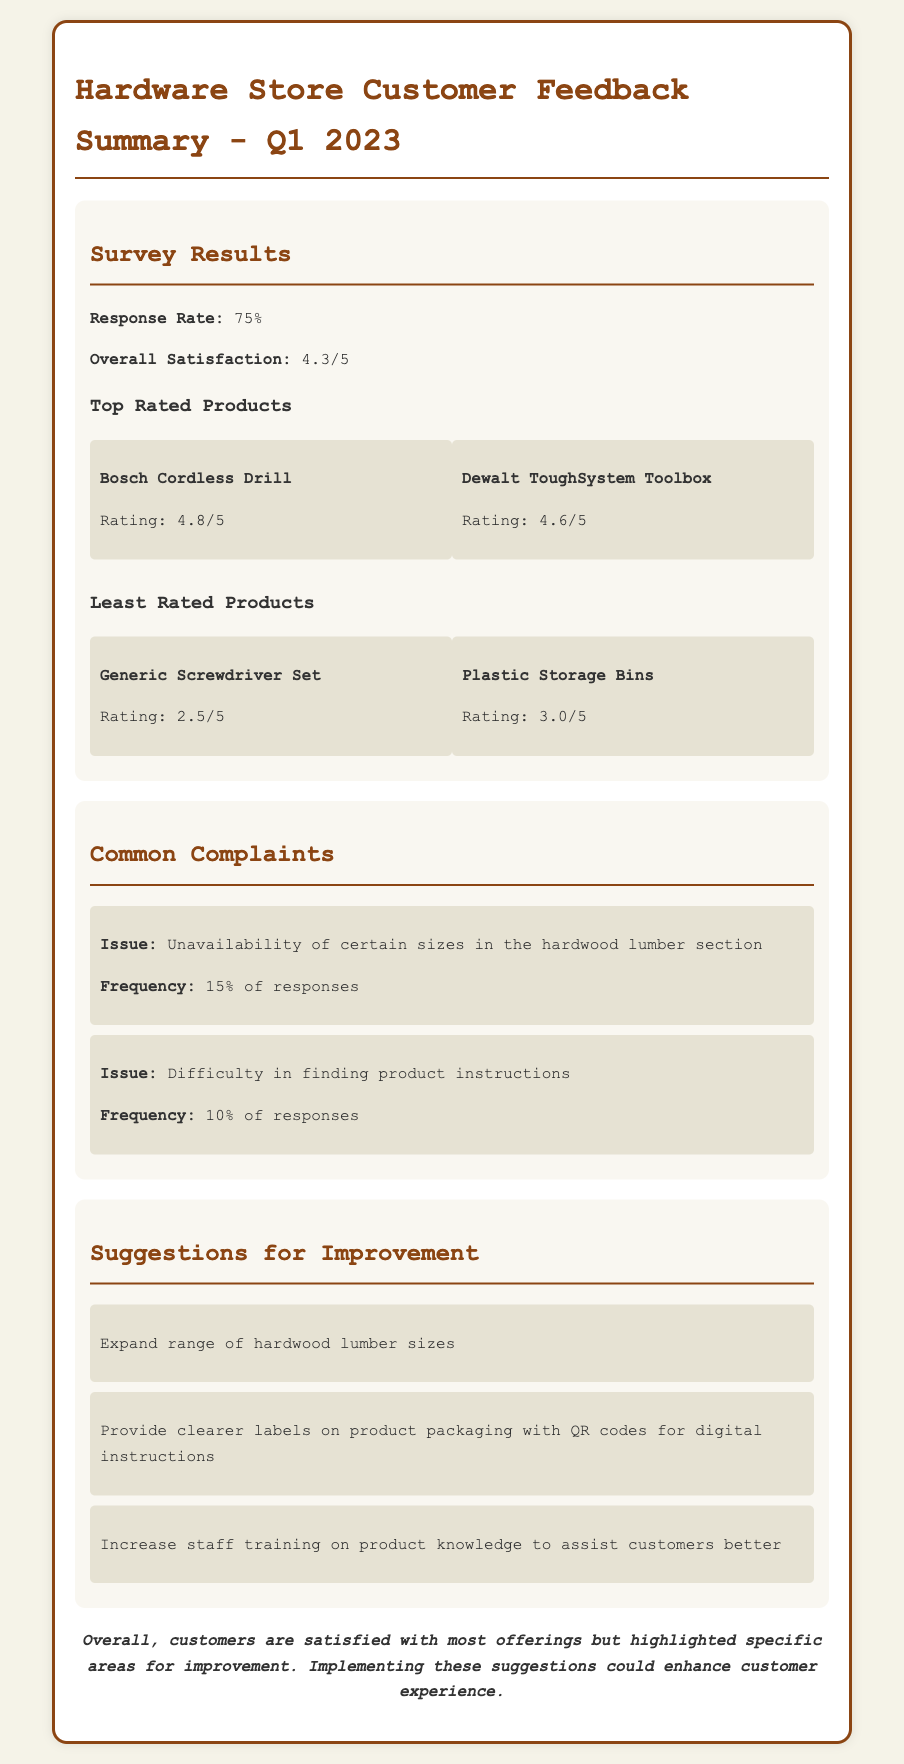What was the response rate for the survey? The response rate indicates how many customers participated in the survey, which is stated as 75%.
Answer: 75% What is the overall satisfaction rating? Overall satisfaction reflects customer happiness, indicated as 4.3 out of 5.
Answer: 4.3/5 Which product received the highest rating? The document lists the top-rated product, which is the Bosch Cordless Drill at 4.8 out of 5.
Answer: Bosch Cordless Drill How frequent was the complaint regarding the unavailability of hardwood lumber sizes? This complaint's frequency is noted in the document as 15% of responses.
Answer: 15% What suggestion was made to enhance product instructions? A suggestion in the document recommends providing clearer labels with QR codes for digital instructions.
Answer: Clearer labels with QR codes Which product had the lowest rating? The least rated product mentioned is the Generic Screwdriver Set with a rating of 2.5 out of 5.
Answer: Generic Screwdriver Set How many suggestions for improvement are provided? The document lists three specific suggestions to improve customer experience.
Answer: Three What was the conclusion on customer satisfaction? The conclusion summarizes that while customers are generally satisfied, there are areas highlighted for improvement.
Answer: Satisfied but needs improvement What percentage of responses indicated difficulty in finding product instructions? The document states that 10% of responses mentioned this difficulty.
Answer: 10% 